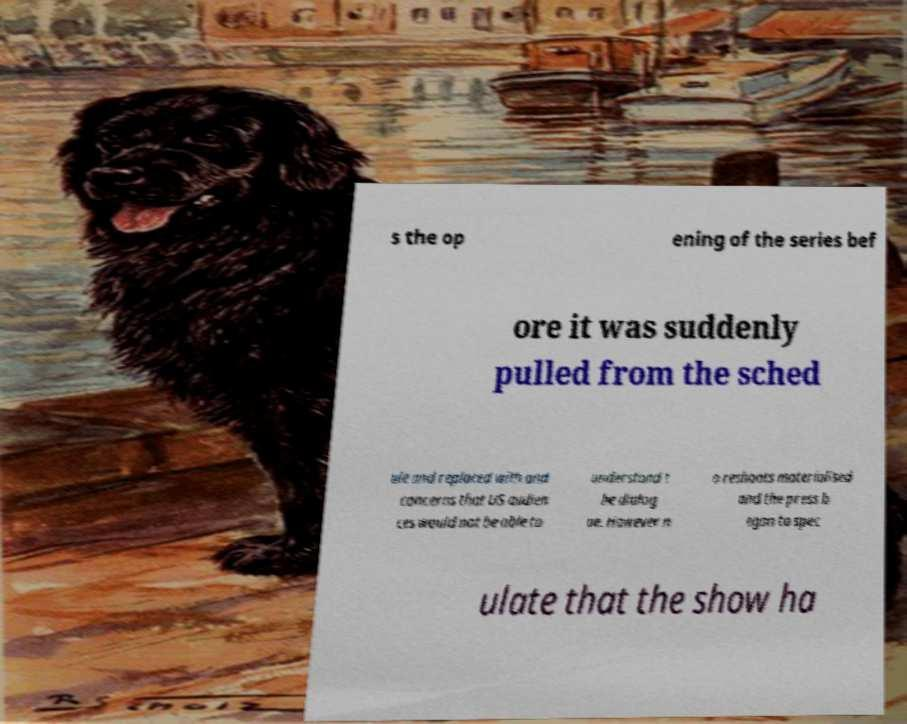I need the written content from this picture converted into text. Can you do that? s the op ening of the series bef ore it was suddenly pulled from the sched ule and replaced with and concerns that US audien ces would not be able to understand t he dialog ue. However n o reshoots materialised and the press b egan to spec ulate that the show ha 